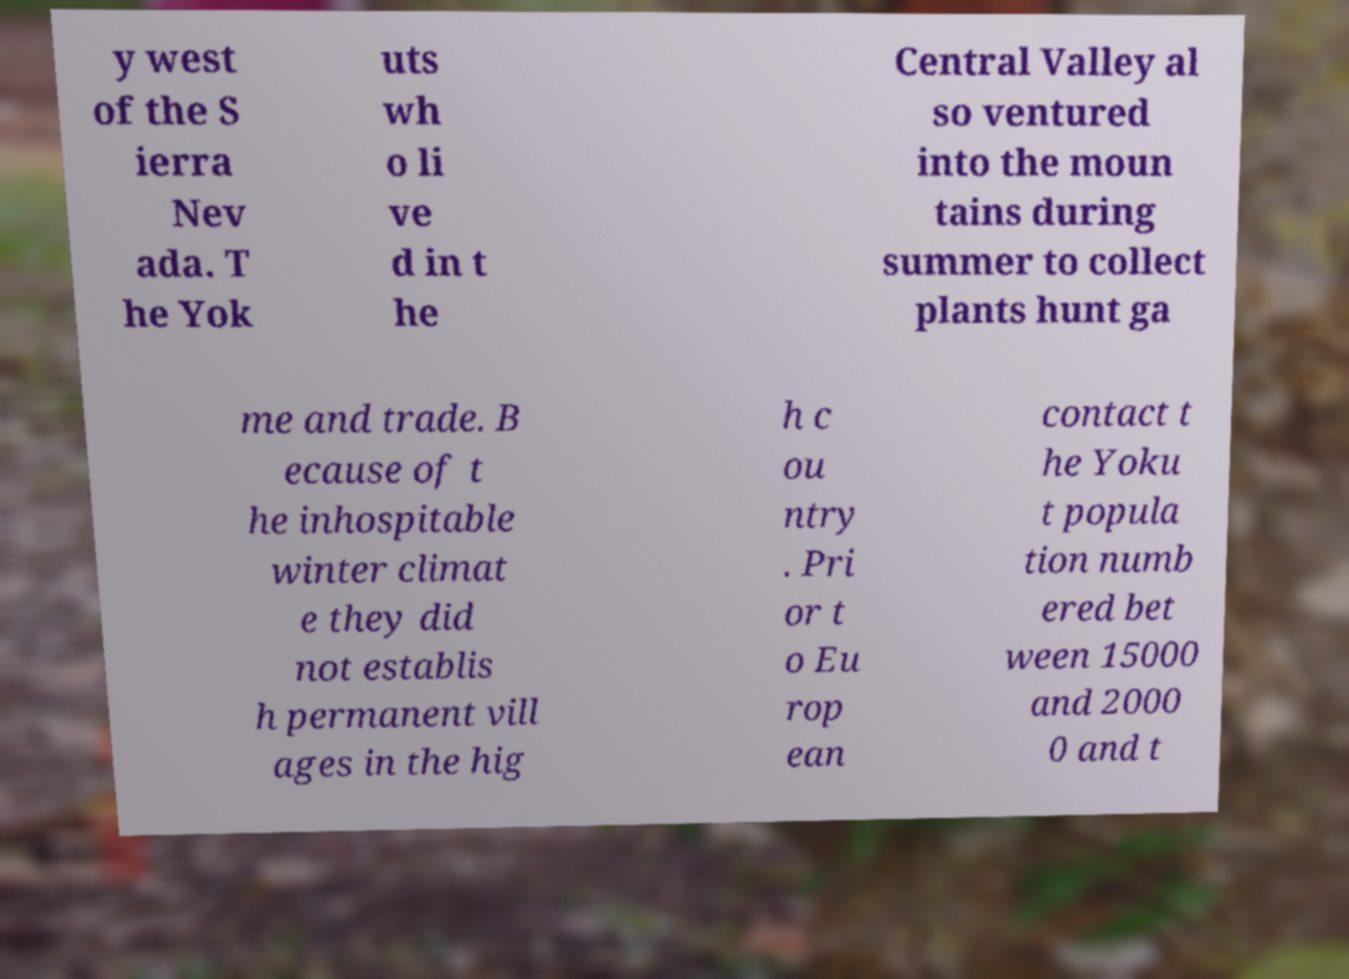Could you extract and type out the text from this image? y west of the S ierra Nev ada. T he Yok uts wh o li ve d in t he Central Valley al so ventured into the moun tains during summer to collect plants hunt ga me and trade. B ecause of t he inhospitable winter climat e they did not establis h permanent vill ages in the hig h c ou ntry . Pri or t o Eu rop ean contact t he Yoku t popula tion numb ered bet ween 15000 and 2000 0 and t 